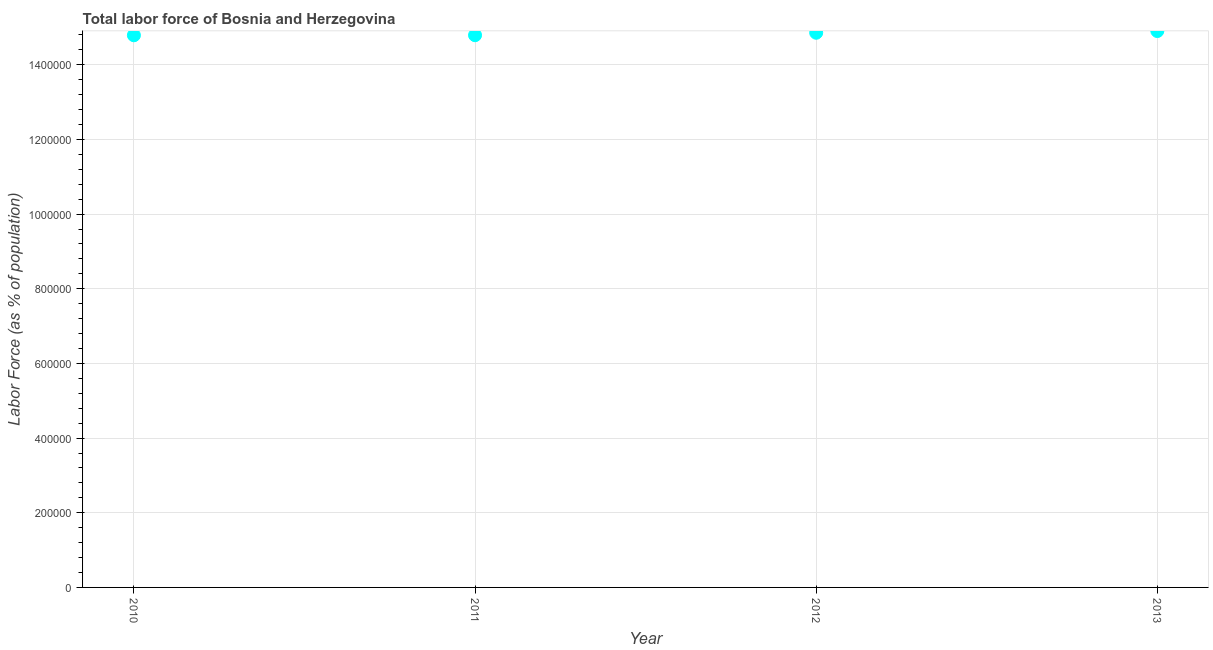What is the total labor force in 2010?
Offer a very short reply. 1.48e+06. Across all years, what is the maximum total labor force?
Provide a short and direct response. 1.49e+06. Across all years, what is the minimum total labor force?
Your answer should be compact. 1.48e+06. In which year was the total labor force maximum?
Provide a short and direct response. 2013. In which year was the total labor force minimum?
Your answer should be very brief. 2010. What is the sum of the total labor force?
Make the answer very short. 5.93e+06. What is the difference between the total labor force in 2010 and 2013?
Offer a very short reply. -1.14e+04. What is the average total labor force per year?
Provide a succinct answer. 1.48e+06. What is the median total labor force?
Keep it short and to the point. 1.48e+06. Do a majority of the years between 2011 and 2013 (inclusive) have total labor force greater than 1320000 %?
Your answer should be very brief. Yes. What is the ratio of the total labor force in 2010 to that in 2012?
Offer a very short reply. 1. Is the total labor force in 2010 less than that in 2012?
Ensure brevity in your answer.  Yes. What is the difference between the highest and the second highest total labor force?
Offer a terse response. 4617. What is the difference between the highest and the lowest total labor force?
Provide a short and direct response. 1.14e+04. In how many years, is the total labor force greater than the average total labor force taken over all years?
Your answer should be compact. 2. Does the total labor force monotonically increase over the years?
Make the answer very short. Yes. How many years are there in the graph?
Keep it short and to the point. 4. Are the values on the major ticks of Y-axis written in scientific E-notation?
Provide a short and direct response. No. Does the graph contain any zero values?
Make the answer very short. No. Does the graph contain grids?
Provide a succinct answer. Yes. What is the title of the graph?
Your answer should be very brief. Total labor force of Bosnia and Herzegovina. What is the label or title of the X-axis?
Your answer should be very brief. Year. What is the label or title of the Y-axis?
Your answer should be very brief. Labor Force (as % of population). What is the Labor Force (as % of population) in 2010?
Offer a very short reply. 1.48e+06. What is the Labor Force (as % of population) in 2011?
Make the answer very short. 1.48e+06. What is the Labor Force (as % of population) in 2012?
Keep it short and to the point. 1.49e+06. What is the Labor Force (as % of population) in 2013?
Offer a terse response. 1.49e+06. What is the difference between the Labor Force (as % of population) in 2010 and 2011?
Make the answer very short. -175. What is the difference between the Labor Force (as % of population) in 2010 and 2012?
Keep it short and to the point. -6743. What is the difference between the Labor Force (as % of population) in 2010 and 2013?
Ensure brevity in your answer.  -1.14e+04. What is the difference between the Labor Force (as % of population) in 2011 and 2012?
Offer a very short reply. -6568. What is the difference between the Labor Force (as % of population) in 2011 and 2013?
Make the answer very short. -1.12e+04. What is the difference between the Labor Force (as % of population) in 2012 and 2013?
Make the answer very short. -4617. What is the ratio of the Labor Force (as % of population) in 2010 to that in 2011?
Provide a succinct answer. 1. What is the ratio of the Labor Force (as % of population) in 2010 to that in 2012?
Your answer should be very brief. 0.99. What is the ratio of the Labor Force (as % of population) in 2010 to that in 2013?
Provide a succinct answer. 0.99. What is the ratio of the Labor Force (as % of population) in 2011 to that in 2012?
Provide a short and direct response. 1. What is the ratio of the Labor Force (as % of population) in 2012 to that in 2013?
Give a very brief answer. 1. 